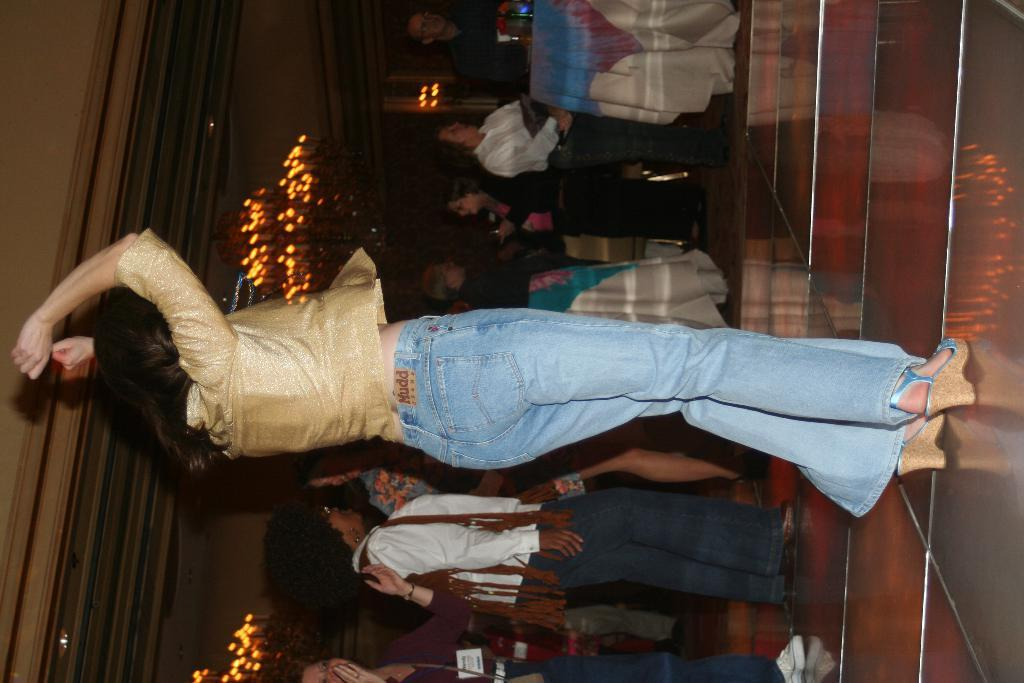What is the woman in the image doing? The woman is dancing in the image. Where is the woman dancing? The woman is dancing on the floor. What can be seen in the background of the image? There are persons, a table, lights, and a wall in the background of the image. What type of hose is being used by the snails in the image? There are no snails or hoses present in the image. Is there a birthday celebration happening in the image? There is no indication of a birthday celebration in the image. 